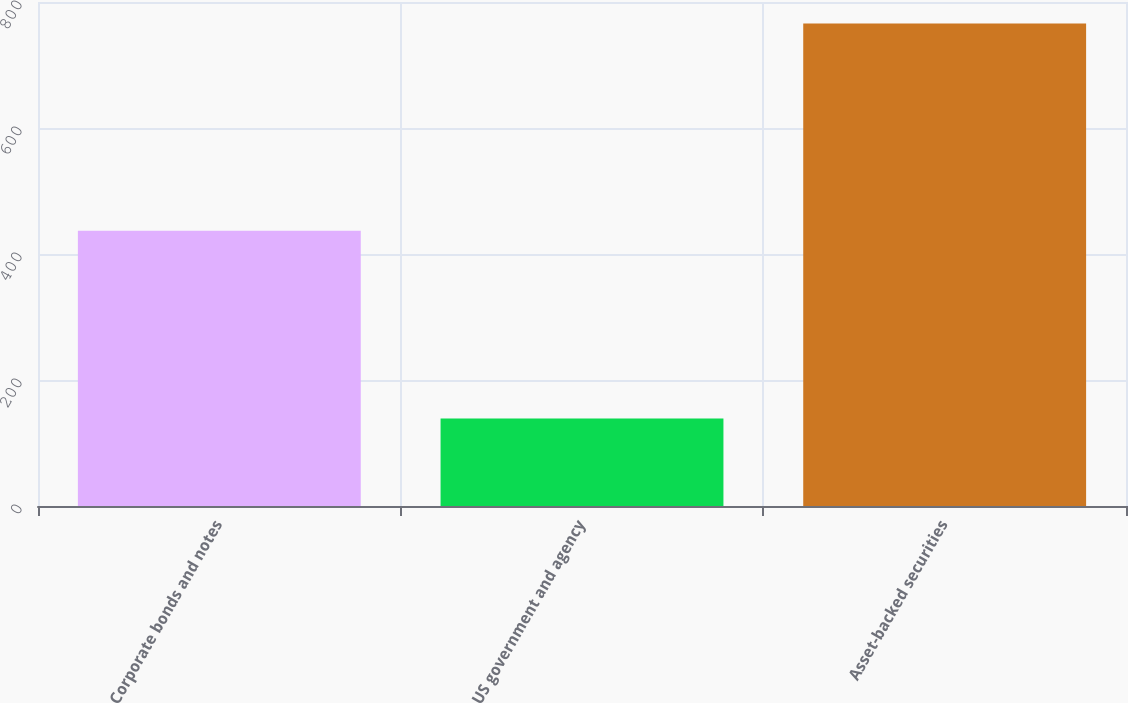Convert chart to OTSL. <chart><loc_0><loc_0><loc_500><loc_500><bar_chart><fcel>Corporate bonds and notes<fcel>US government and agency<fcel>Asset-backed securities<nl><fcel>437<fcel>139<fcel>766<nl></chart> 